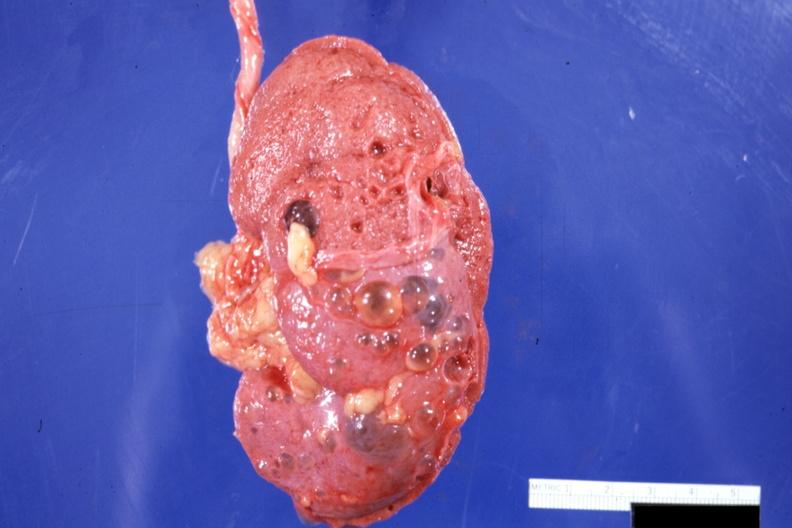does 70yof show external view with capsule stripped?
Answer the question using a single word or phrase. No 